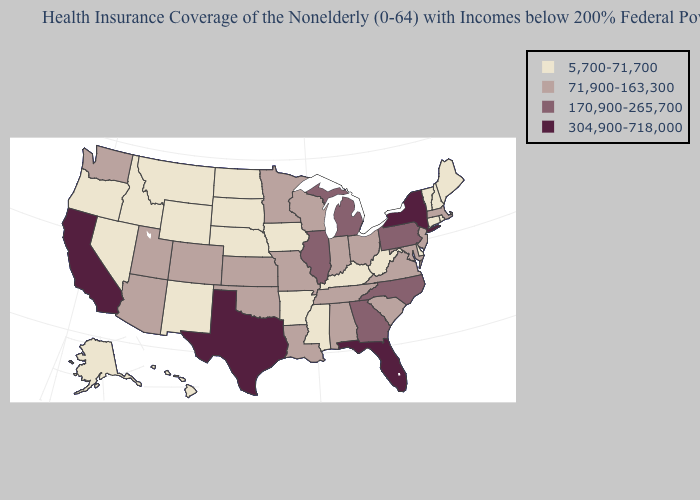What is the value of Alaska?
Quick response, please. 5,700-71,700. Does Kansas have a lower value than Georgia?
Give a very brief answer. Yes. Does Tennessee have a higher value than Hawaii?
Give a very brief answer. Yes. What is the value of Utah?
Write a very short answer. 71,900-163,300. What is the lowest value in the MidWest?
Concise answer only. 5,700-71,700. Does Hawaii have the same value as Alaska?
Short answer required. Yes. Name the states that have a value in the range 71,900-163,300?
Write a very short answer. Alabama, Arizona, Colorado, Indiana, Kansas, Louisiana, Maryland, Massachusetts, Minnesota, Missouri, New Jersey, Ohio, Oklahoma, South Carolina, Tennessee, Utah, Virginia, Washington, Wisconsin. How many symbols are there in the legend?
Short answer required. 4. What is the value of North Carolina?
Write a very short answer. 170,900-265,700. Among the states that border Arkansas , does Texas have the highest value?
Short answer required. Yes. Name the states that have a value in the range 304,900-718,000?
Be succinct. California, Florida, New York, Texas. What is the lowest value in the USA?
Quick response, please. 5,700-71,700. Does the first symbol in the legend represent the smallest category?
Write a very short answer. Yes. Name the states that have a value in the range 170,900-265,700?
Be succinct. Georgia, Illinois, Michigan, North Carolina, Pennsylvania. What is the value of Connecticut?
Write a very short answer. 5,700-71,700. 